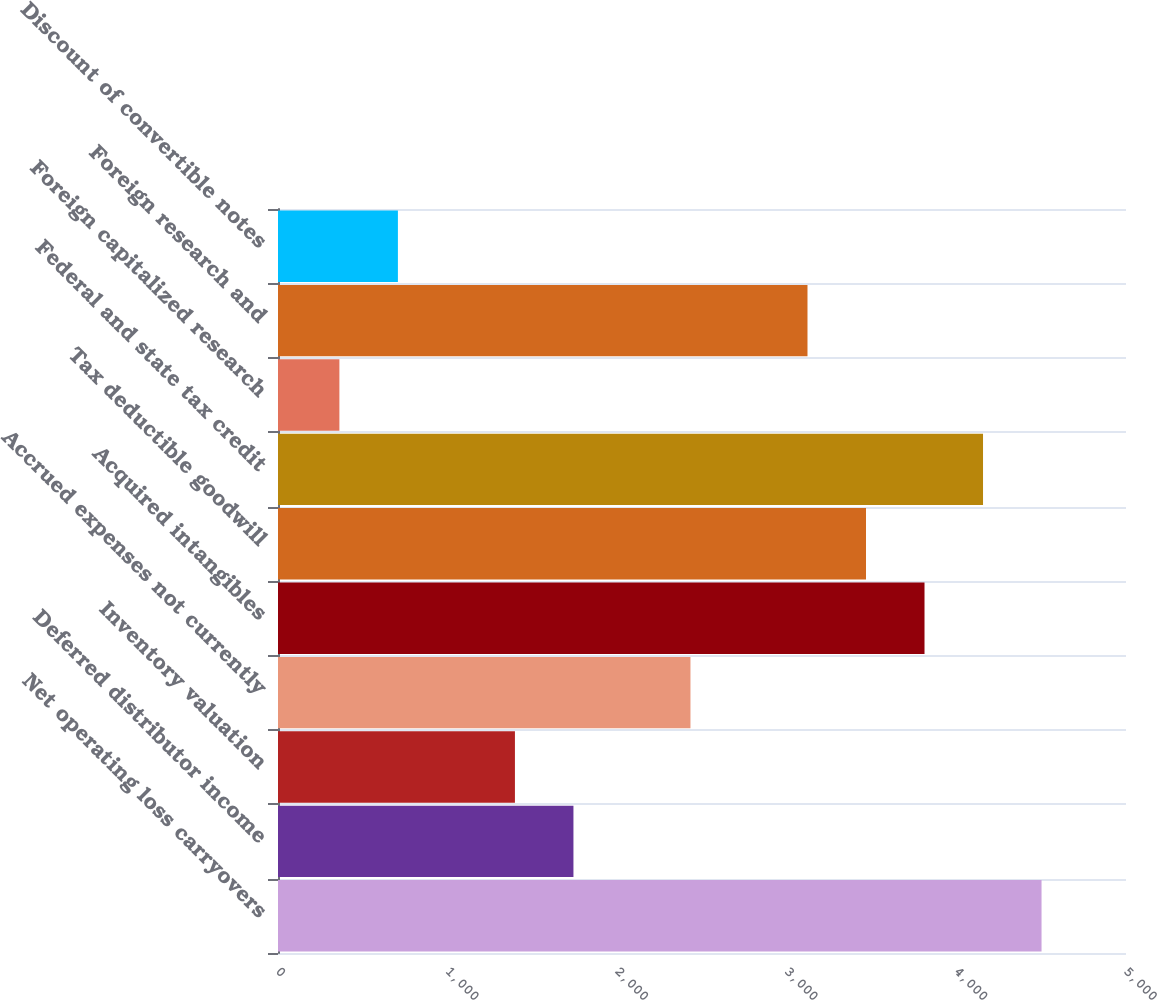<chart> <loc_0><loc_0><loc_500><loc_500><bar_chart><fcel>Net operating loss carryovers<fcel>Deferred distributor income<fcel>Inventory valuation<fcel>Accrued expenses not currently<fcel>Acquired intangibles<fcel>Tax deductible goodwill<fcel>Federal and state tax credit<fcel>Foreign capitalized research<fcel>Foreign research and<fcel>Discount of convertible notes<nl><fcel>4502<fcel>1742<fcel>1397<fcel>2432<fcel>3812<fcel>3467<fcel>4157<fcel>362<fcel>3122<fcel>707<nl></chart> 